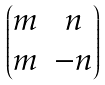Convert formula to latex. <formula><loc_0><loc_0><loc_500><loc_500>\begin{pmatrix} m & n \\ m & - n \end{pmatrix}</formula> 